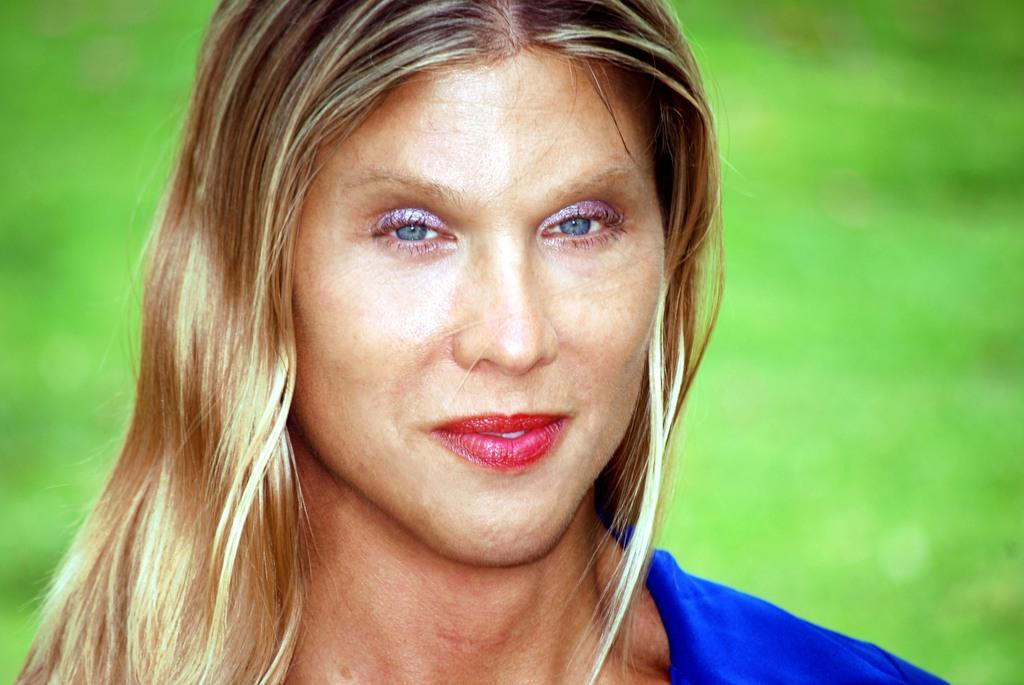Who is present in the image? There is a woman in the image. What is the woman wearing? The woman is wearing a blue dress. What can be seen in the background of the image? The background of the image is green. What type of sticks are being used in the meeting depicted in the image? There is no meeting or sticks present in the image; it features a woman wearing a blue dress against a green background. 